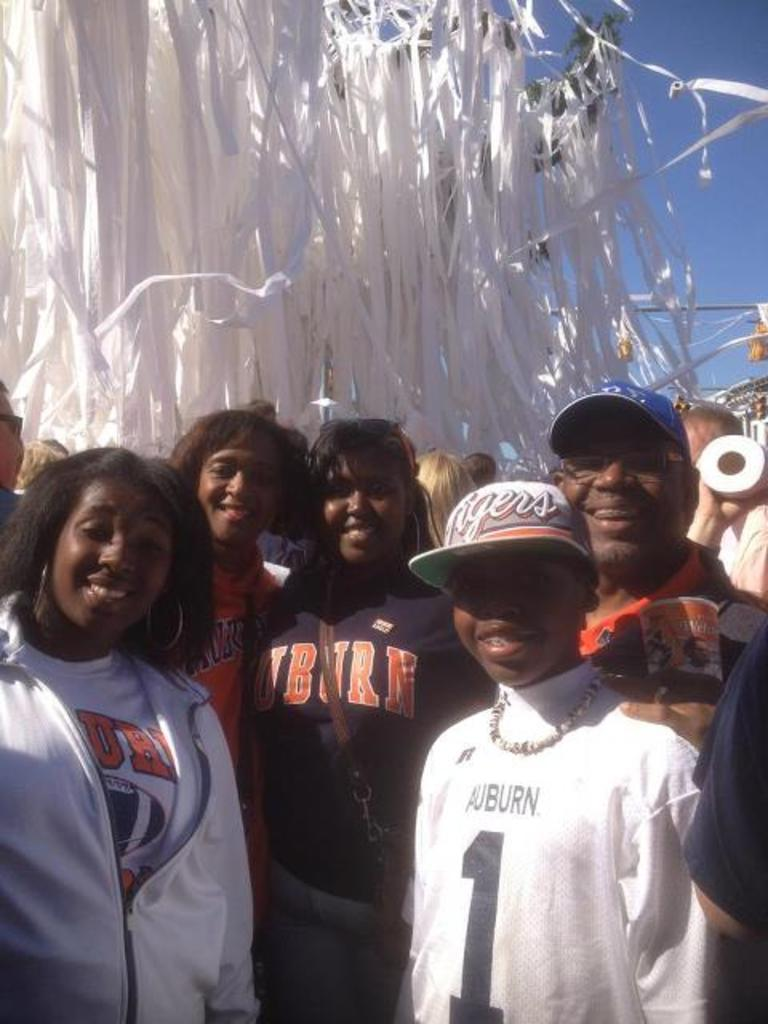What can be observed about the people in the image? There are people standing in the image. What are some of the people wearing? Some of the people are wearing caps. What type of vegetation is present in the image? There is a tree in the image. What type of structure is visible in the image? There is a building in the image. What is the color of the sky in the image? The sky is blue in the image. What type of sound can be heard coming from the tree in the image? There is no sound coming from the tree in the image. What is the texture of the chin of the person on the left in the image? There is no chin visible for the person on the left in the image. 